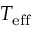<formula> <loc_0><loc_0><loc_500><loc_500>T _ { e f f }</formula> 